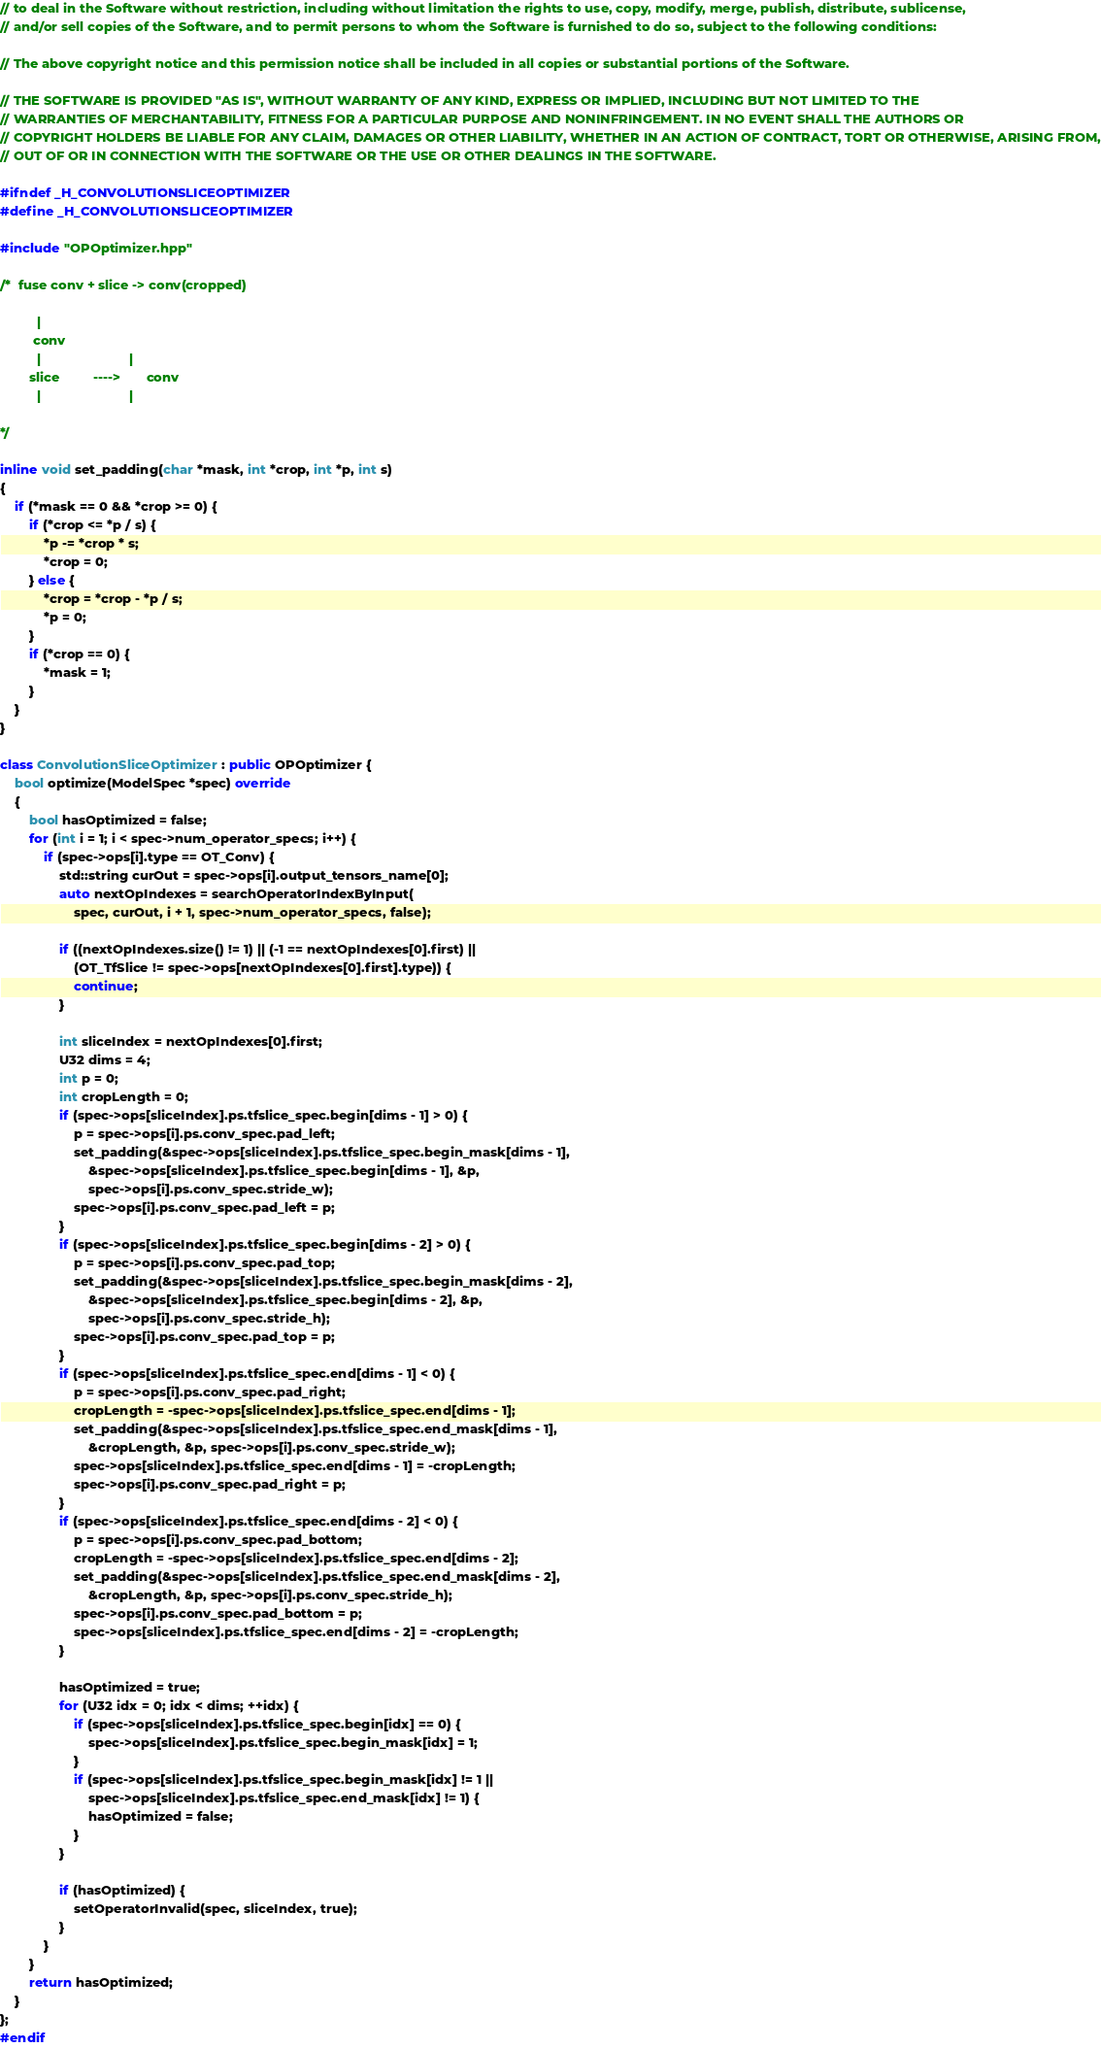<code> <loc_0><loc_0><loc_500><loc_500><_C++_>// to deal in the Software without restriction, including without limitation the rights to use, copy, modify, merge, publish, distribute, sublicense,
// and/or sell copies of the Software, and to permit persons to whom the Software is furnished to do so, subject to the following conditions:

// The above copyright notice and this permission notice shall be included in all copies or substantial portions of the Software.

// THE SOFTWARE IS PROVIDED "AS IS", WITHOUT WARRANTY OF ANY KIND, EXPRESS OR IMPLIED, INCLUDING BUT NOT LIMITED TO THE
// WARRANTIES OF MERCHANTABILITY, FITNESS FOR A PARTICULAR PURPOSE AND NONINFRINGEMENT. IN NO EVENT SHALL THE AUTHORS OR
// COPYRIGHT HOLDERS BE LIABLE FOR ANY CLAIM, DAMAGES OR OTHER LIABILITY, WHETHER IN AN ACTION OF CONTRACT, TORT OR OTHERWISE, ARISING FROM,
// OUT OF OR IN CONNECTION WITH THE SOFTWARE OR THE USE OR OTHER DEALINGS IN THE SOFTWARE.

#ifndef _H_CONVOLUTIONSLICEOPTIMIZER
#define _H_CONVOLUTIONSLICEOPTIMIZER

#include "OPOptimizer.hpp"

/*  fuse conv + slice -> conv(cropped)

          |               
         conv           
          |                        |
        slice         ---->       conv
          |                        |        

*/

inline void set_padding(char *mask, int *crop, int *p, int s)
{
    if (*mask == 0 && *crop >= 0) {
        if (*crop <= *p / s) {
            *p -= *crop * s;
            *crop = 0;
        } else {
            *crop = *crop - *p / s;
            *p = 0;
        }
        if (*crop == 0) {
            *mask = 1;
        }
    }
}

class ConvolutionSliceOptimizer : public OPOptimizer {
    bool optimize(ModelSpec *spec) override
    {
        bool hasOptimized = false;
        for (int i = 1; i < spec->num_operator_specs; i++) {
            if (spec->ops[i].type == OT_Conv) {
                std::string curOut = spec->ops[i].output_tensors_name[0];
                auto nextOpIndexes = searchOperatorIndexByInput(
                    spec, curOut, i + 1, spec->num_operator_specs, false);

                if ((nextOpIndexes.size() != 1) || (-1 == nextOpIndexes[0].first) ||
                    (OT_TfSlice != spec->ops[nextOpIndexes[0].first].type)) {
                    continue;
                }

                int sliceIndex = nextOpIndexes[0].first;
                U32 dims = 4;
                int p = 0;
                int cropLength = 0;
                if (spec->ops[sliceIndex].ps.tfslice_spec.begin[dims - 1] > 0) {
                    p = spec->ops[i].ps.conv_spec.pad_left;
                    set_padding(&spec->ops[sliceIndex].ps.tfslice_spec.begin_mask[dims - 1],
                        &spec->ops[sliceIndex].ps.tfslice_spec.begin[dims - 1], &p,
                        spec->ops[i].ps.conv_spec.stride_w);
                    spec->ops[i].ps.conv_spec.pad_left = p;
                }
                if (spec->ops[sliceIndex].ps.tfslice_spec.begin[dims - 2] > 0) {
                    p = spec->ops[i].ps.conv_spec.pad_top;
                    set_padding(&spec->ops[sliceIndex].ps.tfslice_spec.begin_mask[dims - 2],
                        &spec->ops[sliceIndex].ps.tfslice_spec.begin[dims - 2], &p,
                        spec->ops[i].ps.conv_spec.stride_h);
                    spec->ops[i].ps.conv_spec.pad_top = p;
                }
                if (spec->ops[sliceIndex].ps.tfslice_spec.end[dims - 1] < 0) {
                    p = spec->ops[i].ps.conv_spec.pad_right;
                    cropLength = -spec->ops[sliceIndex].ps.tfslice_spec.end[dims - 1];
                    set_padding(&spec->ops[sliceIndex].ps.tfslice_spec.end_mask[dims - 1],
                        &cropLength, &p, spec->ops[i].ps.conv_spec.stride_w);
                    spec->ops[sliceIndex].ps.tfslice_spec.end[dims - 1] = -cropLength;
                    spec->ops[i].ps.conv_spec.pad_right = p;
                }
                if (spec->ops[sliceIndex].ps.tfslice_spec.end[dims - 2] < 0) {
                    p = spec->ops[i].ps.conv_spec.pad_bottom;
                    cropLength = -spec->ops[sliceIndex].ps.tfslice_spec.end[dims - 2];
                    set_padding(&spec->ops[sliceIndex].ps.tfslice_spec.end_mask[dims - 2],
                        &cropLength, &p, spec->ops[i].ps.conv_spec.stride_h);
                    spec->ops[i].ps.conv_spec.pad_bottom = p;
                    spec->ops[sliceIndex].ps.tfslice_spec.end[dims - 2] = -cropLength;
                }

                hasOptimized = true;
                for (U32 idx = 0; idx < dims; ++idx) {
                    if (spec->ops[sliceIndex].ps.tfslice_spec.begin[idx] == 0) {
                        spec->ops[sliceIndex].ps.tfslice_spec.begin_mask[idx] = 1;
                    }
                    if (spec->ops[sliceIndex].ps.tfslice_spec.begin_mask[idx] != 1 ||
                        spec->ops[sliceIndex].ps.tfslice_spec.end_mask[idx] != 1) {
                        hasOptimized = false;
                    }
                }

                if (hasOptimized) {
                    setOperatorInvalid(spec, sliceIndex, true);
                }
            }
        }
        return hasOptimized;
    }
};
#endif
</code> 